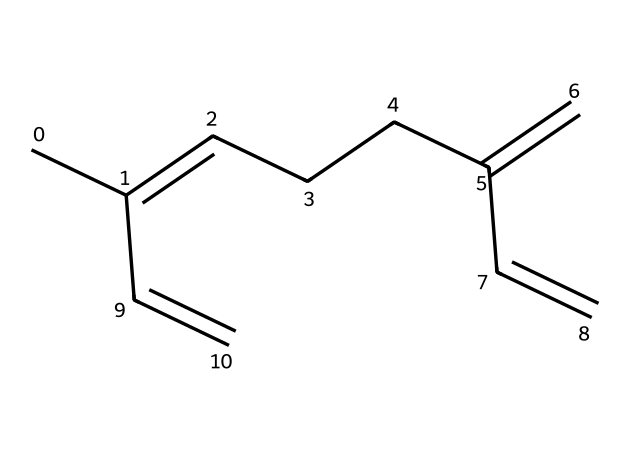how many carbon atoms are in myrcene? By examining the SMILES representation, we count the number of 'C' characters, which represent carbon atoms. In this case, there are 10 carbon atoms present.
Answer: 10 how many double bonds does myrcene have? The structure can be analyzed by looking for '=' signs, which indicate double bonds. There are 3 '=' signs in the SMILES, indicating the presence of 3 double bonds.
Answer: 3 what is the molecular formula of myrcene? To find the molecular formula, we count the carbon and hydrogen atoms. There are 10 carbons and 16 hydrogens, leading us to the formula C10H16.
Answer: C10H16 what type of terpene is myrcene classified as? Myrcene is a monoterpene because it is composed of two isoprene units, which is characteristic of monoterpenes.
Answer: monoterpene which functional groups are present in myrcene? By analyzing the SMILES representation, we see that myrcene does not have any functional groups such as hydroxyl or carboxyl; it is primarily an alkene due to the presence of double bonds.
Answer: alkene how does the structure of myrcene compare to limonene? Myrcene and limonene are both monoterpenes, but they differ in the arrangement of their double bonds; myrcene has a more branched structure compared to the linear structure of limonene.
Answer: more branched what aromatic properties does myrcene exhibit? Myrcene does not exhibit aromatic properties as it lacks a benzene ring or similar structure, which is necessary for aromaticity; hence, it is classified as non-aromatic.
Answer: non-aromatic 